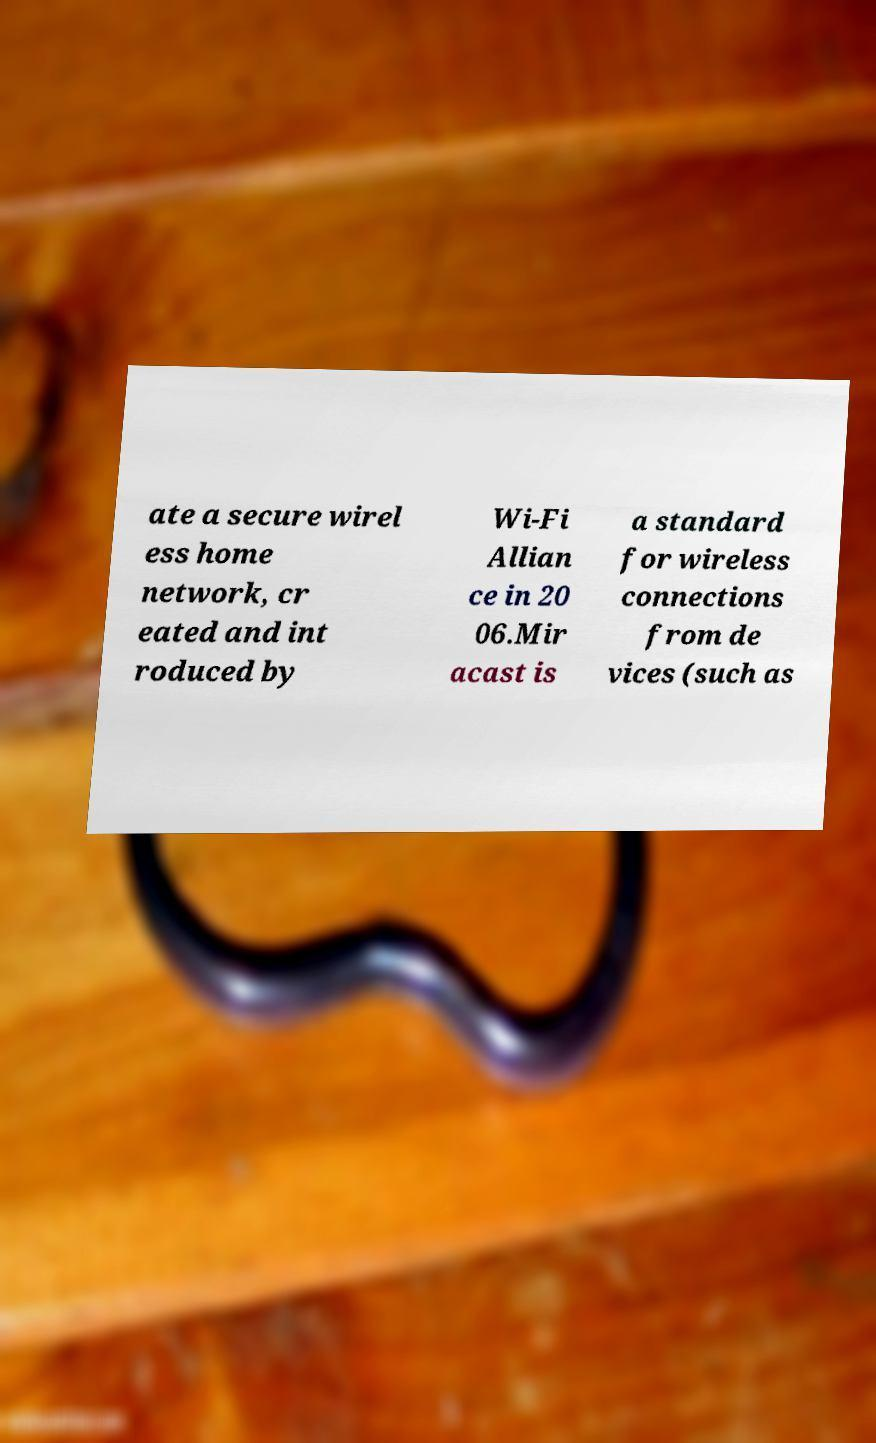Can you accurately transcribe the text from the provided image for me? ate a secure wirel ess home network, cr eated and int roduced by Wi-Fi Allian ce in 20 06.Mir acast is a standard for wireless connections from de vices (such as 